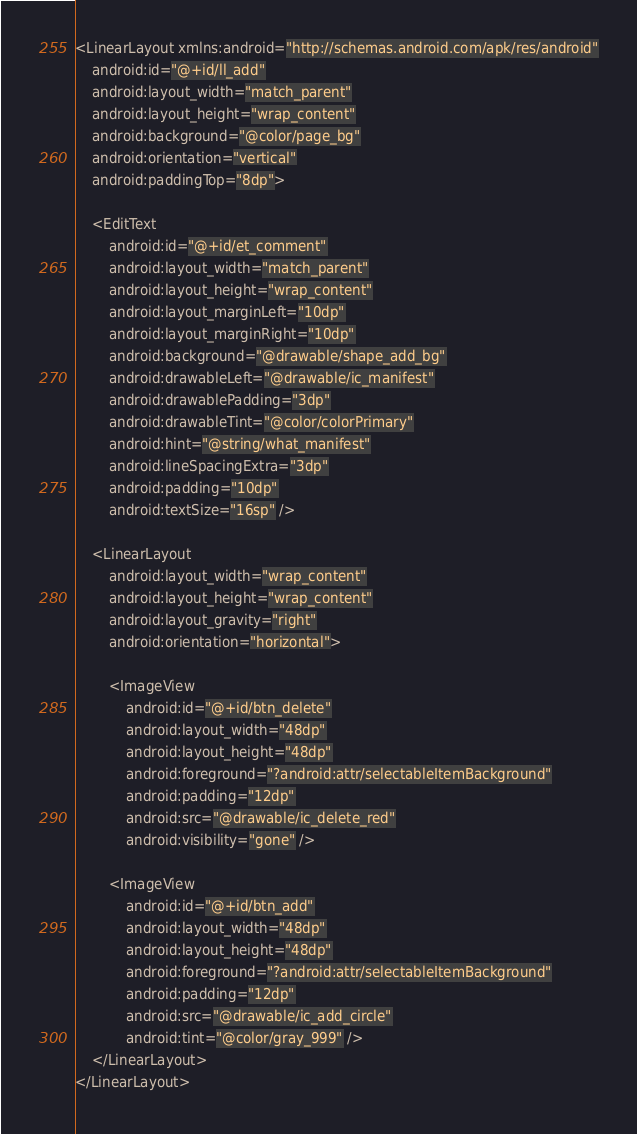Convert code to text. <code><loc_0><loc_0><loc_500><loc_500><_XML_><LinearLayout xmlns:android="http://schemas.android.com/apk/res/android"
    android:id="@+id/ll_add"
    android:layout_width="match_parent"
    android:layout_height="wrap_content"
    android:background="@color/page_bg"
    android:orientation="vertical"
    android:paddingTop="8dp">

    <EditText
        android:id="@+id/et_comment"
        android:layout_width="match_parent"
        android:layout_height="wrap_content"
        android:layout_marginLeft="10dp"
        android:layout_marginRight="10dp"
        android:background="@drawable/shape_add_bg"
        android:drawableLeft="@drawable/ic_manifest"
        android:drawablePadding="3dp"
        android:drawableTint="@color/colorPrimary"
        android:hint="@string/what_manifest"
        android:lineSpacingExtra="3dp"
        android:padding="10dp"
        android:textSize="16sp" />

    <LinearLayout
        android:layout_width="wrap_content"
        android:layout_height="wrap_content"
        android:layout_gravity="right"
        android:orientation="horizontal">

        <ImageView
            android:id="@+id/btn_delete"
            android:layout_width="48dp"
            android:layout_height="48dp"
            android:foreground="?android:attr/selectableItemBackground"
            android:padding="12dp"
            android:src="@drawable/ic_delete_red"
            android:visibility="gone" />

        <ImageView
            android:id="@+id/btn_add"
            android:layout_width="48dp"
            android:layout_height="48dp"
            android:foreground="?android:attr/selectableItemBackground"
            android:padding="12dp"
            android:src="@drawable/ic_add_circle"
            android:tint="@color/gray_999" />
    </LinearLayout>
</LinearLayout></code> 